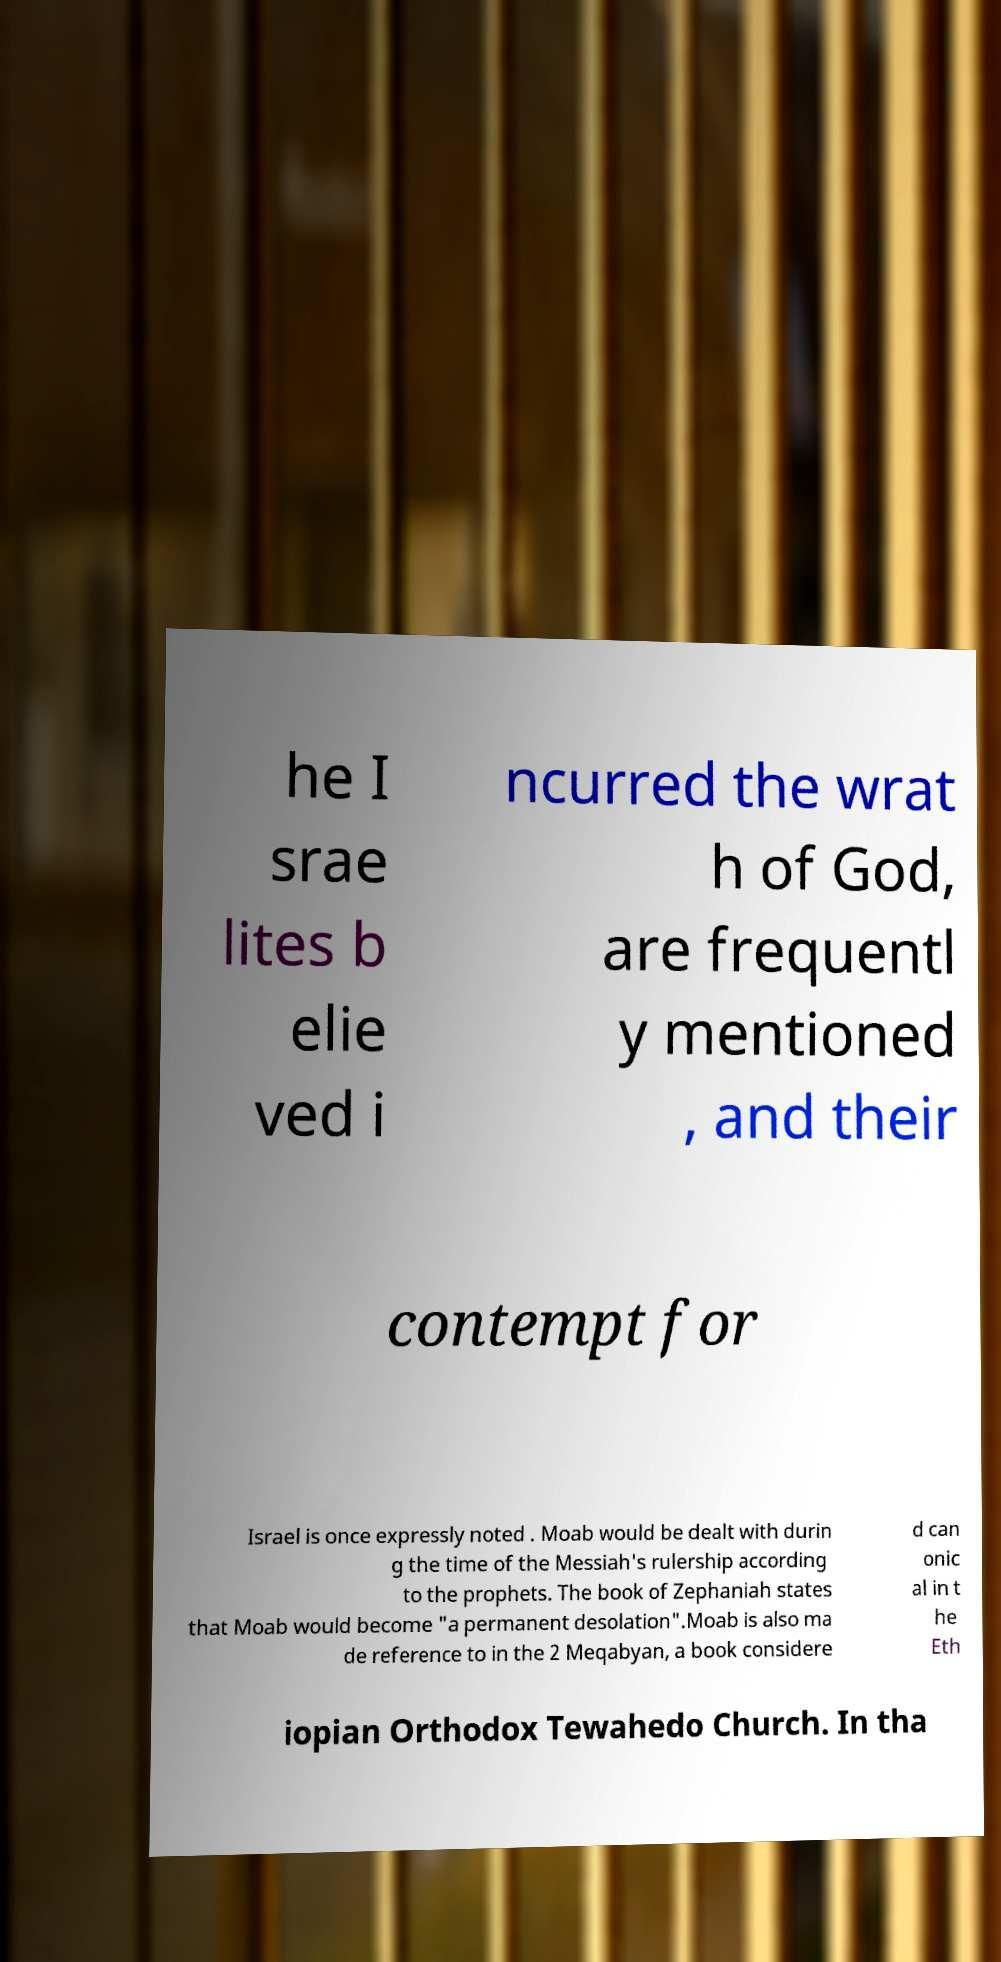Please identify and transcribe the text found in this image. he I srae lites b elie ved i ncurred the wrat h of God, are frequentl y mentioned , and their contempt for Israel is once expressly noted . Moab would be dealt with durin g the time of the Messiah's rulership according to the prophets. The book of Zephaniah states that Moab would become "a permanent desolation".Moab is also ma de reference to in the 2 Meqabyan, a book considere d can onic al in t he Eth iopian Orthodox Tewahedo Church. In tha 